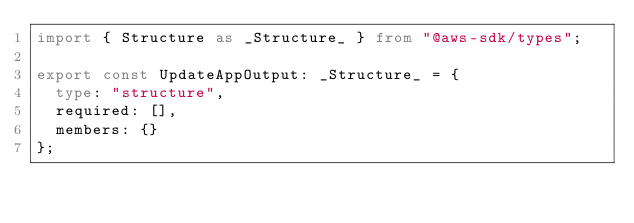Convert code to text. <code><loc_0><loc_0><loc_500><loc_500><_TypeScript_>import { Structure as _Structure_ } from "@aws-sdk/types";

export const UpdateAppOutput: _Structure_ = {
  type: "structure",
  required: [],
  members: {}
};
</code> 